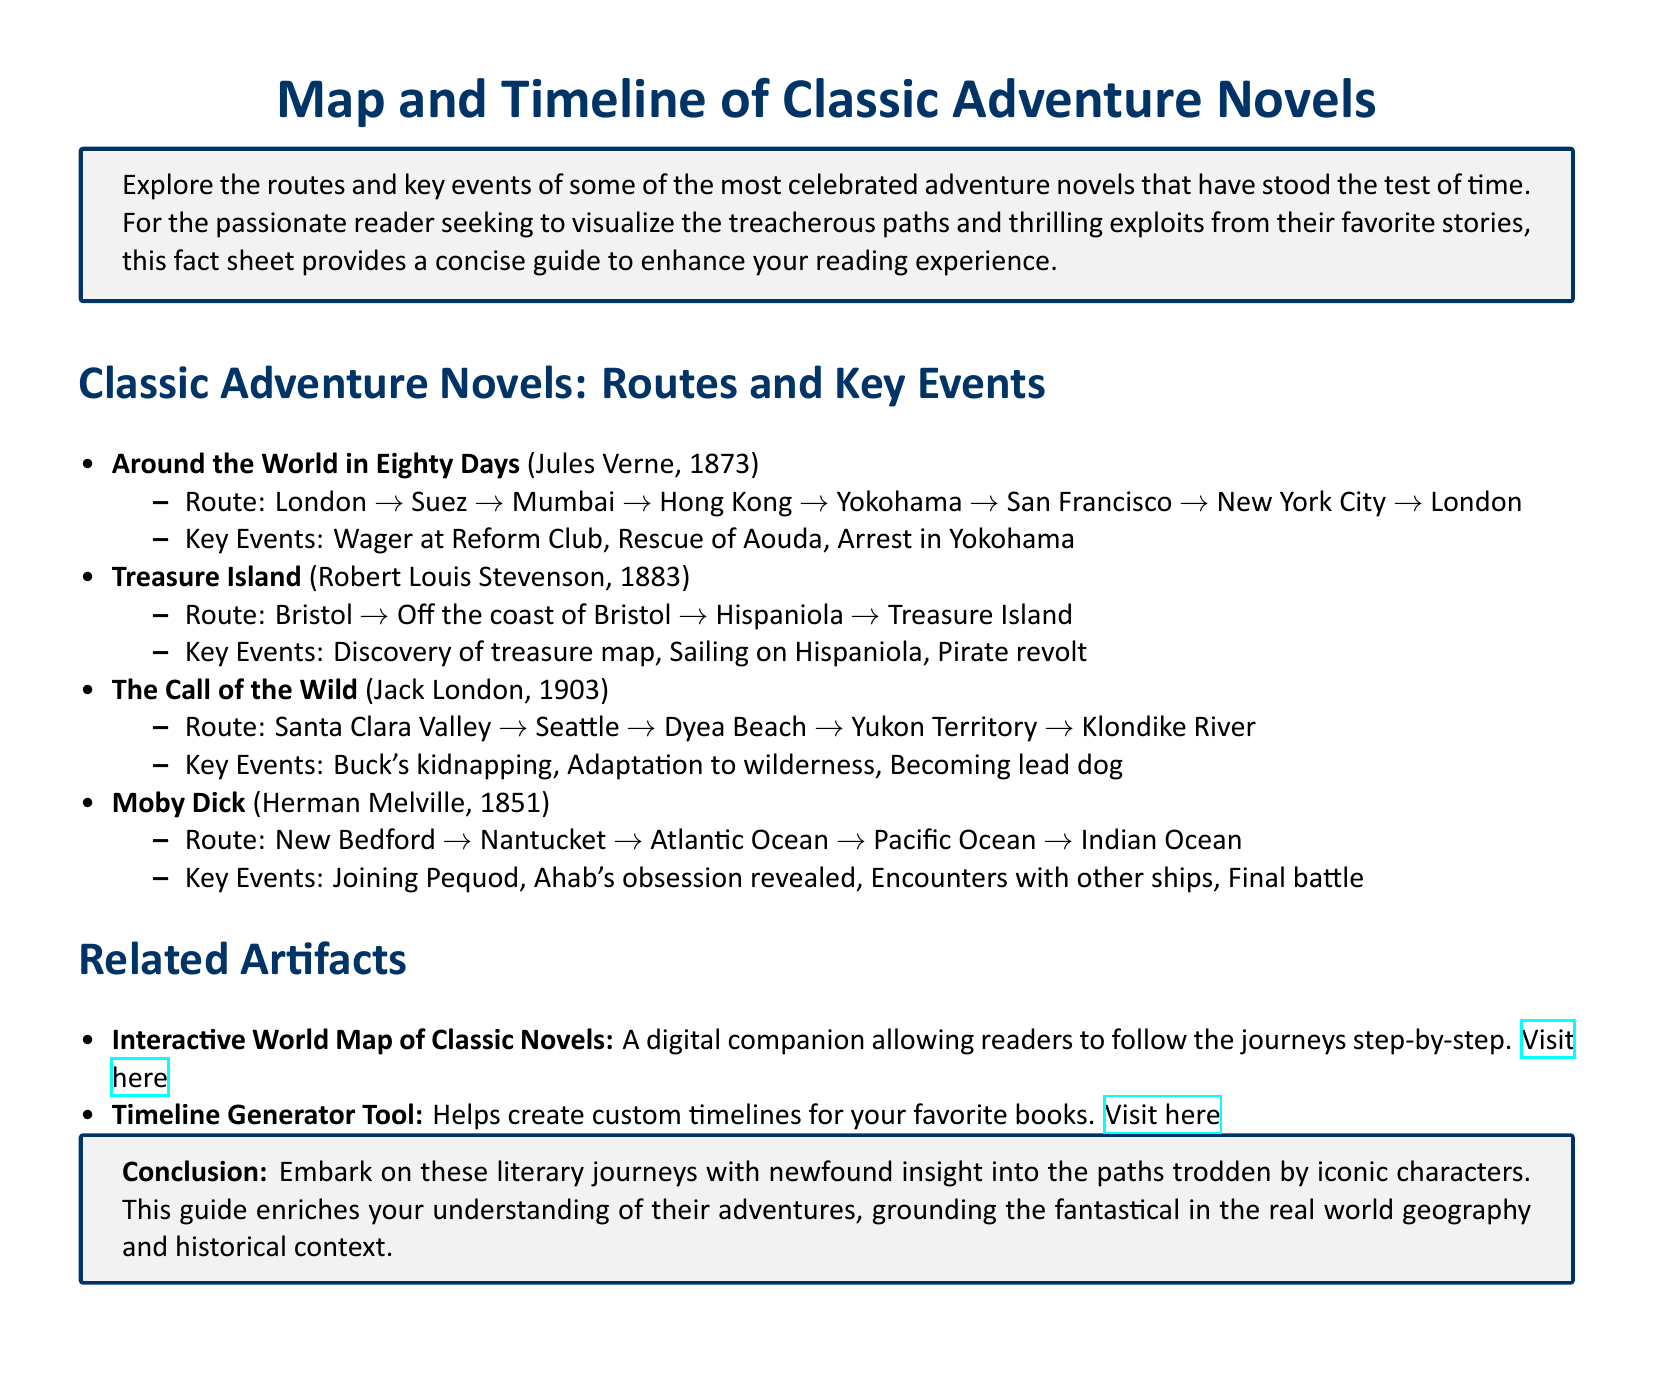What is the title of the first novel listed? The first novel listed is "Around the World in Eighty Days."
Answer: Around the World in Eighty Days Who wrote "Treasure Island"? The author of "Treasure Island" is Robert Louis Stevenson.
Answer: Robert Louis Stevenson How many key events are listed for "The Call of the Wild"? The document covers three key events for "The Call of the Wild."
Answer: Three What is the route in "Moby Dick"? The route in "Moby Dick" includes multiple locations including New Bedford and the Atlantic Ocean.
Answer: New Bedford to Indian Ocean Which novel features a character named Ahab? The character Ahab appears in "Moby Dick."
Answer: Moby Dick What tool does the document provide to create custom timelines? The document mentions a tool called the "Timeline Generator Tool."
Answer: Timeline Generator Tool How many classic adventure novels are mentioned in the document? There are four classic adventure novels mentioned in the document.
Answer: Four What is the interactive map's purpose? The interactive map allows readers to follow the journeys of classic novels step-by-step.
Answer: Follow journeys step-by-step 